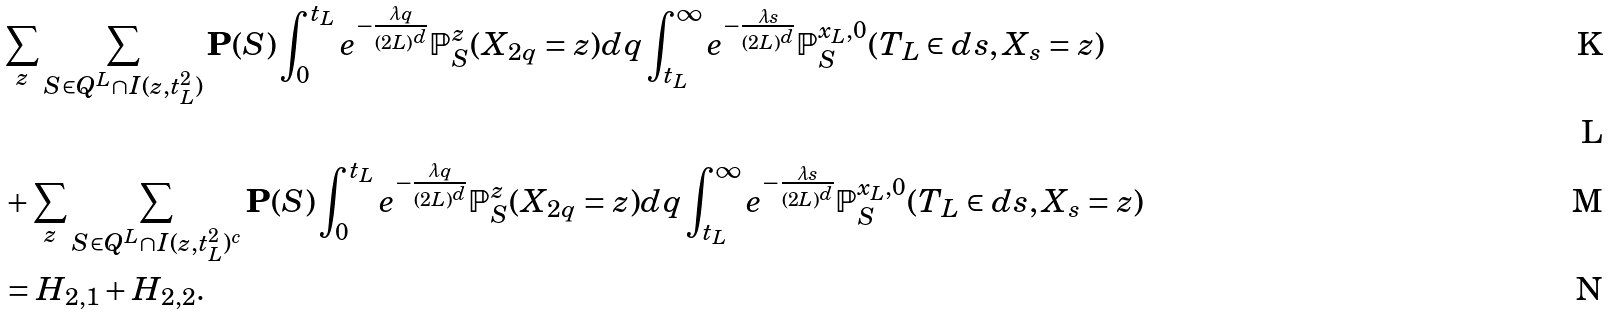<formula> <loc_0><loc_0><loc_500><loc_500>& \sum _ { z } \sum _ { S \in Q ^ { L } \cap I ( z , t _ { L } ^ { 2 } ) } \mathbf P ( S ) \int _ { 0 } ^ { t _ { L } } e ^ { - \frac { \lambda q } { ( 2 L ) ^ { d } } } \mathbb { P } _ { S } ^ { z } ( X _ { 2 q } = z ) d q \int _ { t _ { L } } ^ { \infty } e ^ { - \frac { \lambda s } { ( 2 L ) ^ { d } } } \mathbb { P } _ { S } ^ { x _ { L } , 0 } ( T _ { L } \in d s , X _ { s } = z ) \\ \\ & + \sum _ { z } \sum _ { S \in Q ^ { L } \cap I ( z , t _ { L } ^ { 2 } ) ^ { c } } \mathbf P ( S ) \int _ { 0 } ^ { t _ { L } } e ^ { - \frac { \lambda q } { ( 2 L ) ^ { d } } } \mathbb { P } _ { S } ^ { z } ( X _ { 2 q } = z ) d q \int _ { t _ { L } } ^ { \infty } e ^ { - \frac { \lambda s } { ( 2 L ) ^ { d } } } \mathbb { P } _ { S } ^ { x _ { L } , 0 } ( T _ { L } \in d s , X _ { s } = z ) \\ & = H _ { 2 , 1 } + H _ { 2 , 2 } .</formula> 